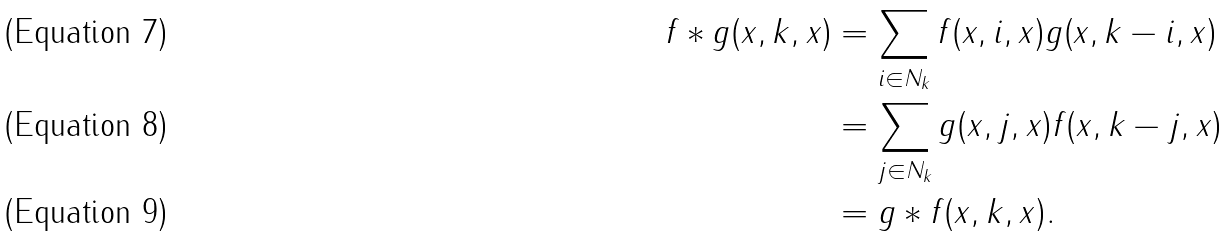Convert formula to latex. <formula><loc_0><loc_0><loc_500><loc_500>f \ast g ( x , k , x ) & = \sum _ { i \in N _ { k } } f ( x , i , x ) g ( x , k - i , x ) \\ & = \sum _ { j \in N _ { k } } g ( x , j , x ) f ( x , k - j , x ) \\ & = g \ast f ( x , k , x ) .</formula> 